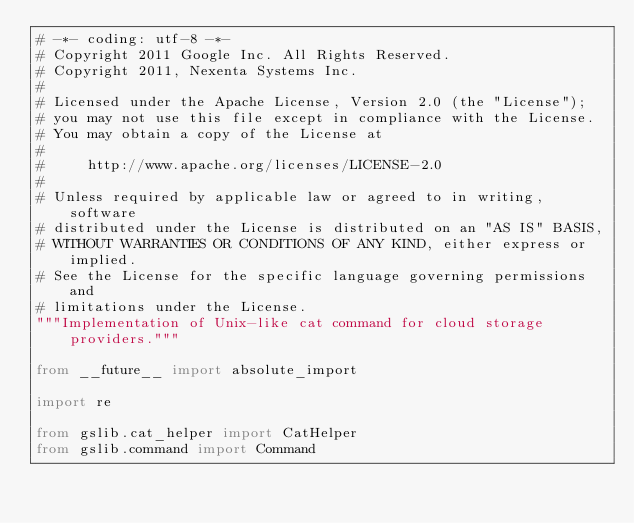<code> <loc_0><loc_0><loc_500><loc_500><_Python_># -*- coding: utf-8 -*-
# Copyright 2011 Google Inc. All Rights Reserved.
# Copyright 2011, Nexenta Systems Inc.
#
# Licensed under the Apache License, Version 2.0 (the "License");
# you may not use this file except in compliance with the License.
# You may obtain a copy of the License at
#
#     http://www.apache.org/licenses/LICENSE-2.0
#
# Unless required by applicable law or agreed to in writing, software
# distributed under the License is distributed on an "AS IS" BASIS,
# WITHOUT WARRANTIES OR CONDITIONS OF ANY KIND, either express or implied.
# See the License for the specific language governing permissions and
# limitations under the License.
"""Implementation of Unix-like cat command for cloud storage providers."""

from __future__ import absolute_import

import re

from gslib.cat_helper import CatHelper
from gslib.command import Command</code> 